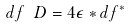<formula> <loc_0><loc_0><loc_500><loc_500>d f \ D = 4 \epsilon * d f ^ { * }</formula> 